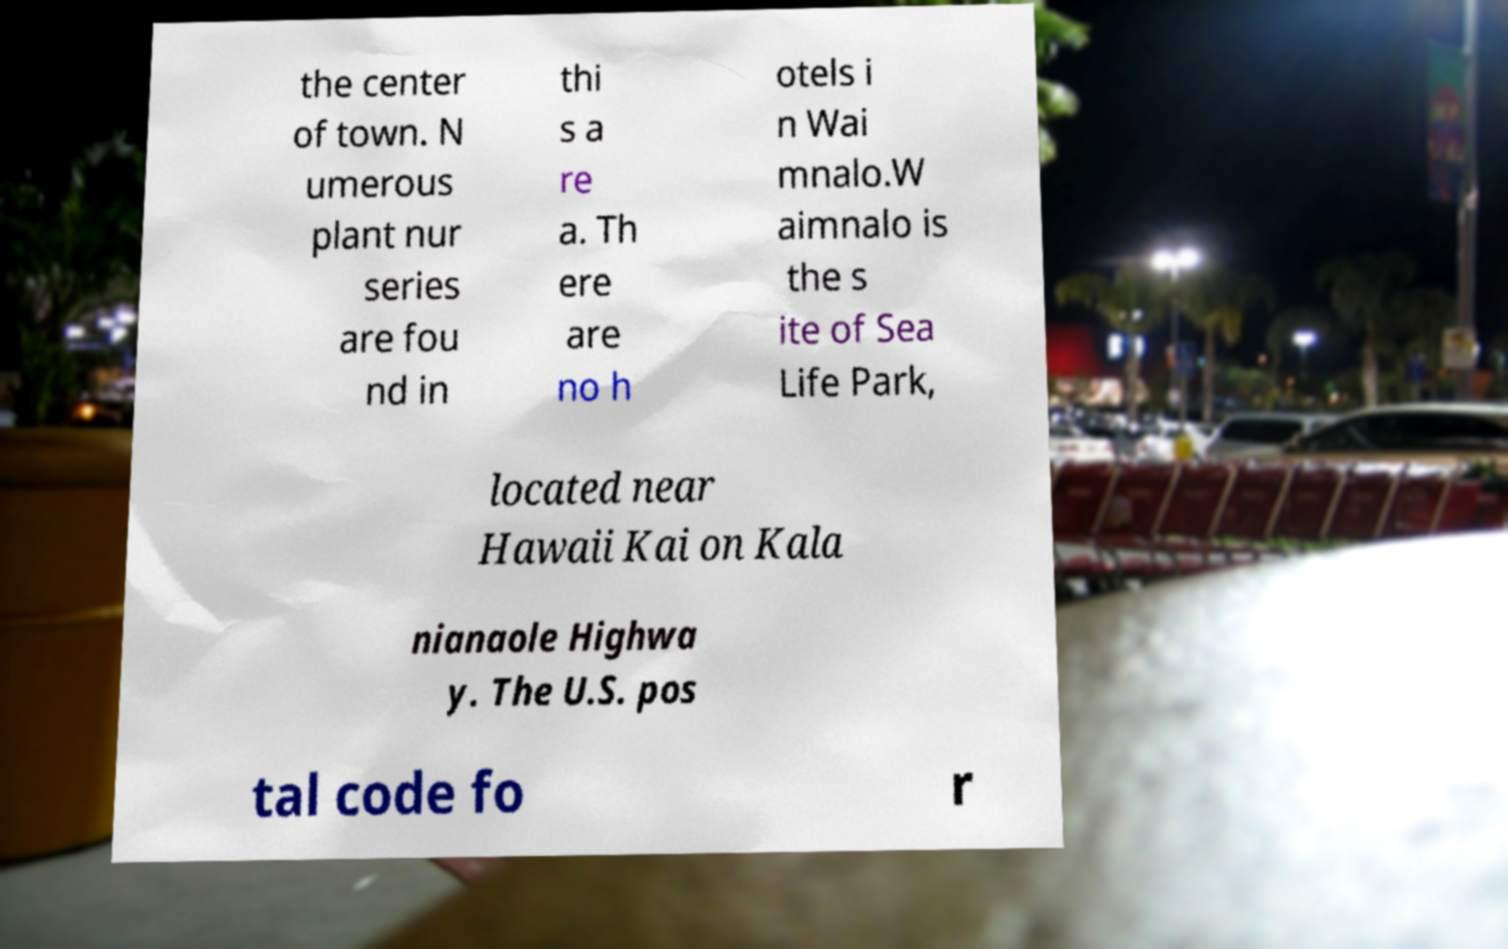I need the written content from this picture converted into text. Can you do that? the center of town. N umerous plant nur series are fou nd in thi s a re a. Th ere are no h otels i n Wai mnalo.W aimnalo is the s ite of Sea Life Park, located near Hawaii Kai on Kala nianaole Highwa y. The U.S. pos tal code fo r 